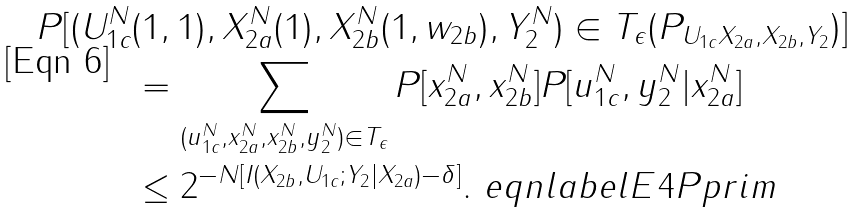<formula> <loc_0><loc_0><loc_500><loc_500>P [ ( U _ { 1 c } ^ { N } & ( 1 , 1 ) , X _ { 2 a } ^ { N } ( 1 ) , X _ { 2 b } ^ { N } ( 1 , w _ { 2 b } ) , Y _ { 2 } ^ { N } ) \in T _ { \epsilon } ( P _ { U _ { 1 c } X _ { 2 a } , X _ { 2 b } , Y _ { 2 } } ) ] \\ & = \sum _ { ( u _ { 1 c } ^ { N } , x _ { 2 a } ^ { N } , x _ { 2 b } ^ { N } , y _ { 2 } ^ { N } ) \in T _ { \epsilon } } P [ x _ { 2 a } ^ { N } , x _ { 2 b } ^ { N } ] P [ u _ { 1 c } ^ { N } , y _ { 2 } ^ { N } | x _ { 2 a } ^ { N } ] \\ & \leq 2 ^ { - N [ I ( X _ { 2 b } , U _ { 1 c } ; Y _ { 2 } | X _ { 2 a } ) - \delta ] } . \ e q n l a b e l { E 4 P p r i m }</formula> 